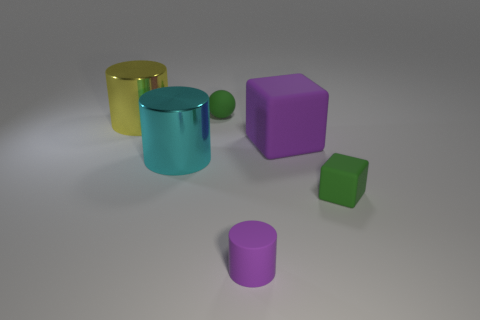What number of yellow things have the same shape as the small purple matte thing?
Ensure brevity in your answer.  1. There is a small rubber object behind the small green matte cube; what is its color?
Offer a terse response. Green. How many matte things are either blocks or tiny purple things?
Your answer should be compact. 3. What shape is the matte object that is the same color as the small matte block?
Offer a terse response. Sphere. How many shiny things are the same size as the rubber ball?
Your answer should be compact. 0. The object that is both behind the big cyan thing and in front of the big yellow metallic cylinder is what color?
Your answer should be compact. Purple. What number of things are either tiny rubber cylinders or large yellow shiny cylinders?
Keep it short and to the point. 2. What number of big things are either matte spheres or yellow objects?
Make the answer very short. 1. Is there anything else that has the same color as the big rubber object?
Keep it short and to the point. Yes. There is a rubber thing that is both on the right side of the tiny purple matte cylinder and in front of the purple matte block; how big is it?
Provide a succinct answer. Small. 